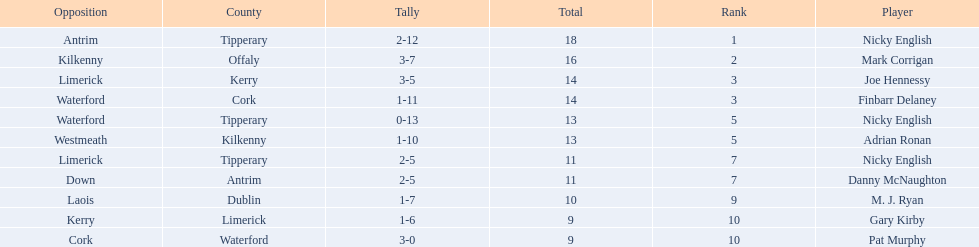Who are all the players? Nicky English, Mark Corrigan, Joe Hennessy, Finbarr Delaney, Nicky English, Adrian Ronan, Nicky English, Danny McNaughton, M. J. Ryan, Gary Kirby, Pat Murphy. How many points did they receive? 18, 16, 14, 14, 13, 13, 11, 11, 10, 9, 9. And which player received 10 points? M. J. Ryan. 